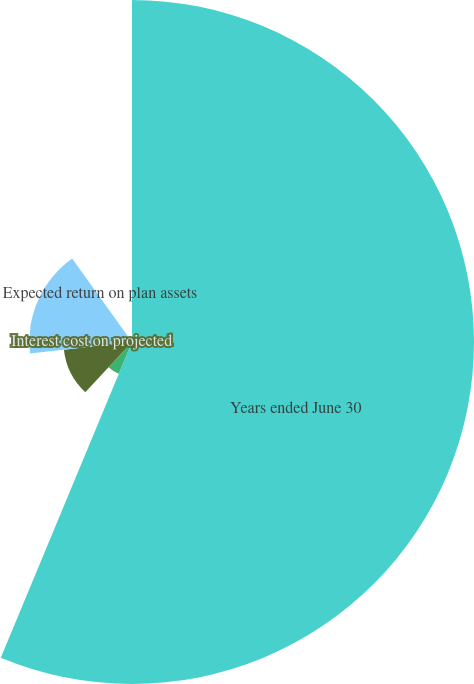Convert chart to OTSL. <chart><loc_0><loc_0><loc_500><loc_500><pie_chart><fcel>Years ended June 30<fcel>during the period<fcel>Interest cost on projected<fcel>Expected return on plan assets<fcel>Amortization of losses<nl><fcel>62.42%<fcel>6.28%<fcel>12.51%<fcel>18.75%<fcel>0.04%<nl></chart> 